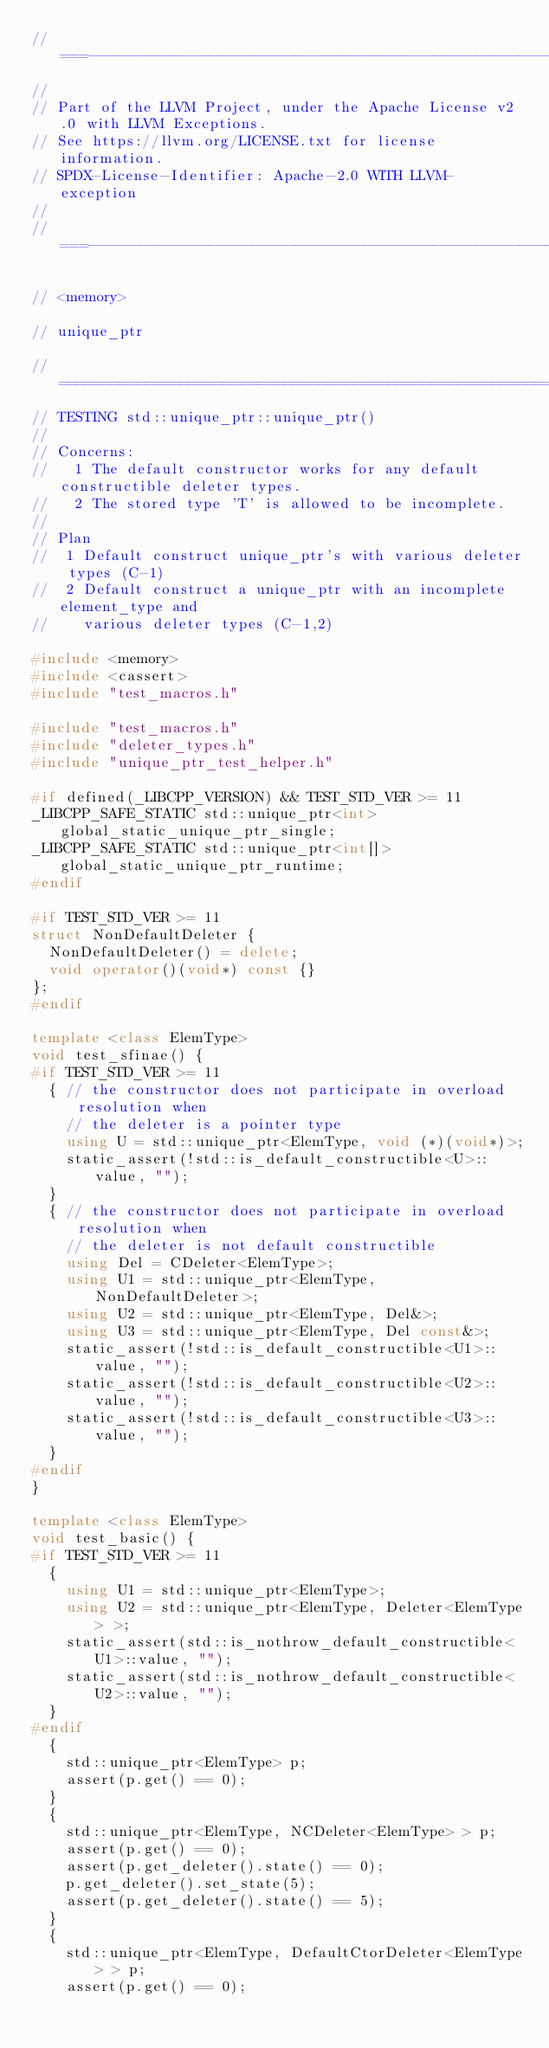<code> <loc_0><loc_0><loc_500><loc_500><_C++_>//===----------------------------------------------------------------------===//
//
// Part of the LLVM Project, under the Apache License v2.0 with LLVM Exceptions.
// See https://llvm.org/LICENSE.txt for license information.
// SPDX-License-Identifier: Apache-2.0 WITH LLVM-exception
//
//===----------------------------------------------------------------------===//

// <memory>

// unique_ptr

//=============================================================================
// TESTING std::unique_ptr::unique_ptr()
//
// Concerns:
//   1 The default constructor works for any default constructible deleter types.
//   2 The stored type 'T' is allowed to be incomplete.
//
// Plan
//  1 Default construct unique_ptr's with various deleter types (C-1)
//  2 Default construct a unique_ptr with an incomplete element_type and
//    various deleter types (C-1,2)

#include <memory>
#include <cassert>
#include "test_macros.h"

#include "test_macros.h"
#include "deleter_types.h"
#include "unique_ptr_test_helper.h"

#if defined(_LIBCPP_VERSION) && TEST_STD_VER >= 11
_LIBCPP_SAFE_STATIC std::unique_ptr<int> global_static_unique_ptr_single;
_LIBCPP_SAFE_STATIC std::unique_ptr<int[]> global_static_unique_ptr_runtime;
#endif

#if TEST_STD_VER >= 11
struct NonDefaultDeleter {
  NonDefaultDeleter() = delete;
  void operator()(void*) const {}
};
#endif

template <class ElemType>
void test_sfinae() {
#if TEST_STD_VER >= 11
  { // the constructor does not participate in overload resolution when
    // the deleter is a pointer type
    using U = std::unique_ptr<ElemType, void (*)(void*)>;
    static_assert(!std::is_default_constructible<U>::value, "");
  }
  { // the constructor does not participate in overload resolution when
    // the deleter is not default constructible
    using Del = CDeleter<ElemType>;
    using U1 = std::unique_ptr<ElemType, NonDefaultDeleter>;
    using U2 = std::unique_ptr<ElemType, Del&>;
    using U3 = std::unique_ptr<ElemType, Del const&>;
    static_assert(!std::is_default_constructible<U1>::value, "");
    static_assert(!std::is_default_constructible<U2>::value, "");
    static_assert(!std::is_default_constructible<U3>::value, "");
  }
#endif
}

template <class ElemType>
void test_basic() {
#if TEST_STD_VER >= 11
  {
    using U1 = std::unique_ptr<ElemType>;
    using U2 = std::unique_ptr<ElemType, Deleter<ElemType> >;
    static_assert(std::is_nothrow_default_constructible<U1>::value, "");
    static_assert(std::is_nothrow_default_constructible<U2>::value, "");
  }
#endif
  {
    std::unique_ptr<ElemType> p;
    assert(p.get() == 0);
  }
  {
    std::unique_ptr<ElemType, NCDeleter<ElemType> > p;
    assert(p.get() == 0);
    assert(p.get_deleter().state() == 0);
    p.get_deleter().set_state(5);
    assert(p.get_deleter().state() == 5);
  }
  {
    std::unique_ptr<ElemType, DefaultCtorDeleter<ElemType> > p;
    assert(p.get() == 0);</code> 